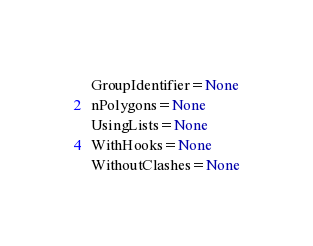Convert code to text. <code><loc_0><loc_0><loc_500><loc_500><_Python_> GroupIdentifier=None
 nPolygons=None
 UsingLists=None
 WithHooks=None
 WithoutClashes=None

</code> 